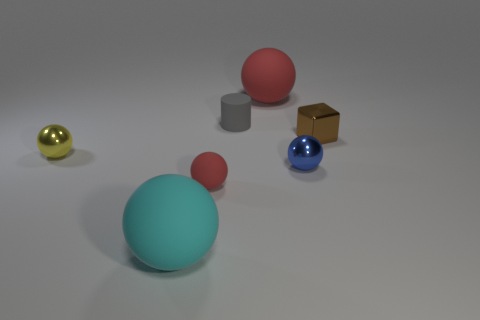Are there any yellow rubber blocks that have the same size as the blue ball?
Ensure brevity in your answer.  No. Do the yellow sphere and the thing right of the tiny blue sphere have the same material?
Your answer should be compact. Yes. Are there more purple metallic cylinders than small gray matte things?
Your answer should be compact. No. What number of cylinders are either large objects or tiny brown objects?
Offer a very short reply. 0. What color is the tiny rubber ball?
Your answer should be compact. Red. There is a thing on the left side of the big cyan thing; does it have the same size as the metallic ball to the right of the large red sphere?
Ensure brevity in your answer.  Yes. Is the number of red spheres less than the number of tiny spheres?
Your answer should be very brief. Yes. What number of blue metallic spheres are to the left of the tiny blue thing?
Offer a terse response. 0. What is the tiny red sphere made of?
Offer a very short reply. Rubber. Do the cylinder and the tiny block have the same color?
Give a very brief answer. No. 